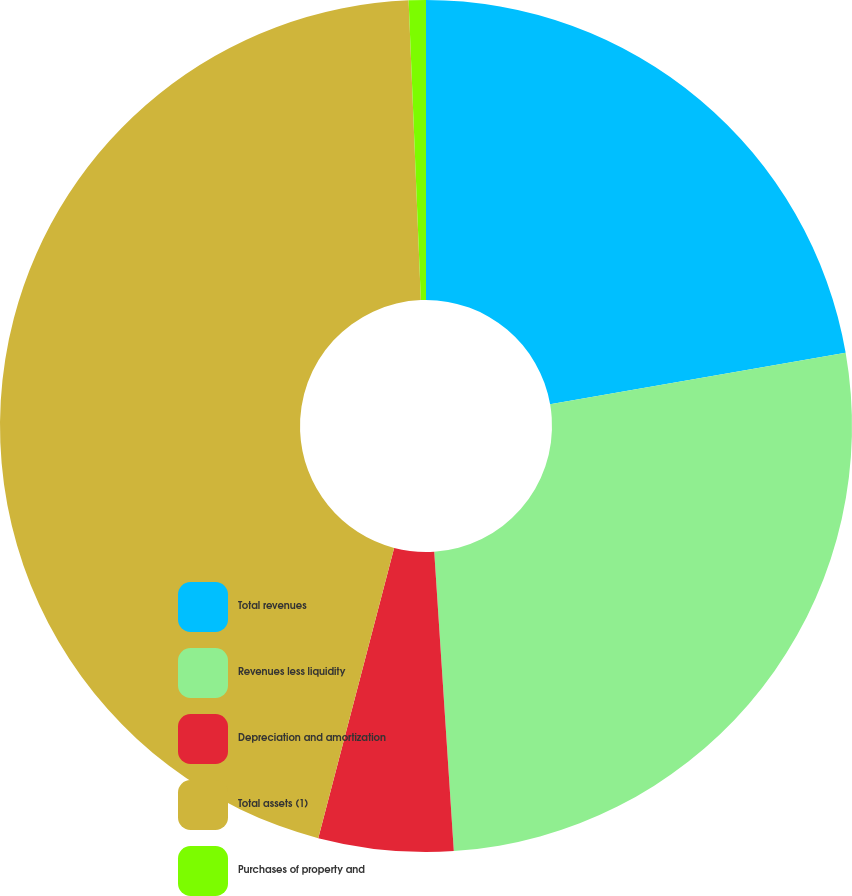Convert chart to OTSL. <chart><loc_0><loc_0><loc_500><loc_500><pie_chart><fcel>Total revenues<fcel>Revenues less liquidity<fcel>Depreciation and amortization<fcel>Total assets (1)<fcel>Purchases of property and<nl><fcel>22.25%<fcel>26.71%<fcel>5.11%<fcel>45.28%<fcel>0.65%<nl></chart> 